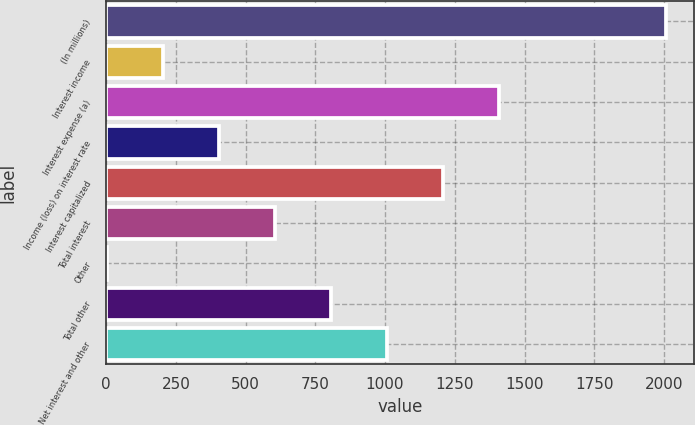<chart> <loc_0><loc_0><loc_500><loc_500><bar_chart><fcel>(In millions)<fcel>Interest income<fcel>Interest expense (a)<fcel>Income (loss) on interest rate<fcel>Interest capitalized<fcel>Total interest<fcel>Other<fcel>Total other<fcel>Net interest and other<nl><fcel>2009<fcel>202.7<fcel>1406.9<fcel>403.4<fcel>1206.2<fcel>604.1<fcel>2<fcel>804.8<fcel>1005.5<nl></chart> 